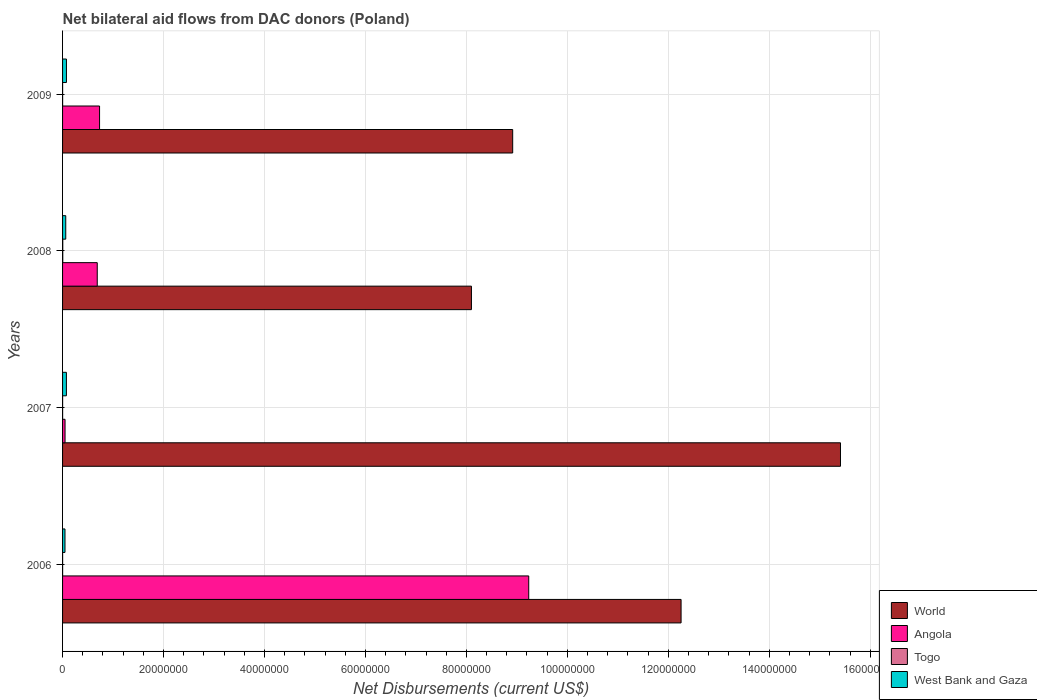Are the number of bars per tick equal to the number of legend labels?
Make the answer very short. Yes. Are the number of bars on each tick of the Y-axis equal?
Your response must be concise. Yes. What is the label of the 2nd group of bars from the top?
Provide a succinct answer. 2008. What is the net bilateral aid flows in West Bank and Gaza in 2009?
Provide a short and direct response. 7.70e+05. Across all years, what is the maximum net bilateral aid flows in World?
Keep it short and to the point. 1.54e+08. Across all years, what is the minimum net bilateral aid flows in West Bank and Gaza?
Your answer should be very brief. 4.80e+05. In which year was the net bilateral aid flows in Togo minimum?
Give a very brief answer. 2006. What is the total net bilateral aid flows in West Bank and Gaza in the graph?
Make the answer very short. 2.64e+06. What is the difference between the net bilateral aid flows in West Bank and Gaza in 2006 and that in 2009?
Provide a short and direct response. -2.90e+05. What is the difference between the net bilateral aid flows in World in 2008 and the net bilateral aid flows in Togo in 2007?
Offer a terse response. 8.10e+07. What is the average net bilateral aid flows in World per year?
Provide a succinct answer. 1.12e+08. In the year 2008, what is the difference between the net bilateral aid flows in Angola and net bilateral aid flows in West Bank and Gaza?
Offer a terse response. 6.24e+06. In how many years, is the net bilateral aid flows in Togo greater than 152000000 US$?
Give a very brief answer. 0. What is the ratio of the net bilateral aid flows in West Bank and Gaza in 2008 to that in 2009?
Ensure brevity in your answer.  0.82. Is the net bilateral aid flows in World in 2006 less than that in 2007?
Give a very brief answer. Yes. Is the difference between the net bilateral aid flows in Angola in 2008 and 2009 greater than the difference between the net bilateral aid flows in West Bank and Gaza in 2008 and 2009?
Offer a terse response. No. What is the difference between the highest and the lowest net bilateral aid flows in World?
Ensure brevity in your answer.  7.31e+07. In how many years, is the net bilateral aid flows in Togo greater than the average net bilateral aid flows in Togo taken over all years?
Your answer should be compact. 1. What does the 4th bar from the top in 2007 represents?
Offer a terse response. World. What does the 1st bar from the bottom in 2007 represents?
Your response must be concise. World. Are all the bars in the graph horizontal?
Provide a succinct answer. Yes. How many years are there in the graph?
Offer a very short reply. 4. Does the graph contain any zero values?
Provide a short and direct response. No. What is the title of the graph?
Your response must be concise. Net bilateral aid flows from DAC donors (Poland). What is the label or title of the X-axis?
Offer a terse response. Net Disbursements (current US$). What is the Net Disbursements (current US$) in World in 2006?
Give a very brief answer. 1.23e+08. What is the Net Disbursements (current US$) of Angola in 2006?
Make the answer very short. 9.24e+07. What is the Net Disbursements (current US$) of Togo in 2006?
Offer a terse response. 10000. What is the Net Disbursements (current US$) of World in 2007?
Your response must be concise. 1.54e+08. What is the Net Disbursements (current US$) in Angola in 2007?
Offer a very short reply. 4.90e+05. What is the Net Disbursements (current US$) in West Bank and Gaza in 2007?
Your response must be concise. 7.60e+05. What is the Net Disbursements (current US$) in World in 2008?
Offer a terse response. 8.10e+07. What is the Net Disbursements (current US$) in Angola in 2008?
Offer a terse response. 6.87e+06. What is the Net Disbursements (current US$) in Togo in 2008?
Provide a short and direct response. 4.00e+04. What is the Net Disbursements (current US$) of West Bank and Gaza in 2008?
Provide a succinct answer. 6.30e+05. What is the Net Disbursements (current US$) of World in 2009?
Offer a very short reply. 8.92e+07. What is the Net Disbursements (current US$) in Angola in 2009?
Make the answer very short. 7.33e+06. What is the Net Disbursements (current US$) in West Bank and Gaza in 2009?
Make the answer very short. 7.70e+05. Across all years, what is the maximum Net Disbursements (current US$) of World?
Ensure brevity in your answer.  1.54e+08. Across all years, what is the maximum Net Disbursements (current US$) of Angola?
Provide a short and direct response. 9.24e+07. Across all years, what is the maximum Net Disbursements (current US$) in West Bank and Gaza?
Your answer should be very brief. 7.70e+05. Across all years, what is the minimum Net Disbursements (current US$) in World?
Offer a terse response. 8.10e+07. Across all years, what is the minimum Net Disbursements (current US$) of Angola?
Your answer should be very brief. 4.90e+05. Across all years, what is the minimum Net Disbursements (current US$) in Togo?
Offer a very short reply. 10000. What is the total Net Disbursements (current US$) in World in the graph?
Your answer should be very brief. 4.47e+08. What is the total Net Disbursements (current US$) in Angola in the graph?
Ensure brevity in your answer.  1.07e+08. What is the total Net Disbursements (current US$) of West Bank and Gaza in the graph?
Offer a terse response. 2.64e+06. What is the difference between the Net Disbursements (current US$) of World in 2006 and that in 2007?
Make the answer very short. -3.16e+07. What is the difference between the Net Disbursements (current US$) in Angola in 2006 and that in 2007?
Provide a short and direct response. 9.19e+07. What is the difference between the Net Disbursements (current US$) of West Bank and Gaza in 2006 and that in 2007?
Offer a terse response. -2.80e+05. What is the difference between the Net Disbursements (current US$) of World in 2006 and that in 2008?
Your response must be concise. 4.15e+07. What is the difference between the Net Disbursements (current US$) of Angola in 2006 and that in 2008?
Offer a terse response. 8.55e+07. What is the difference between the Net Disbursements (current US$) in West Bank and Gaza in 2006 and that in 2008?
Provide a short and direct response. -1.50e+05. What is the difference between the Net Disbursements (current US$) of World in 2006 and that in 2009?
Keep it short and to the point. 3.34e+07. What is the difference between the Net Disbursements (current US$) in Angola in 2006 and that in 2009?
Your answer should be compact. 8.50e+07. What is the difference between the Net Disbursements (current US$) of Togo in 2006 and that in 2009?
Your response must be concise. 0. What is the difference between the Net Disbursements (current US$) in World in 2007 and that in 2008?
Keep it short and to the point. 7.31e+07. What is the difference between the Net Disbursements (current US$) in Angola in 2007 and that in 2008?
Provide a short and direct response. -6.38e+06. What is the difference between the Net Disbursements (current US$) of Togo in 2007 and that in 2008?
Your answer should be very brief. -3.00e+04. What is the difference between the Net Disbursements (current US$) of West Bank and Gaza in 2007 and that in 2008?
Offer a very short reply. 1.30e+05. What is the difference between the Net Disbursements (current US$) of World in 2007 and that in 2009?
Offer a terse response. 6.49e+07. What is the difference between the Net Disbursements (current US$) of Angola in 2007 and that in 2009?
Keep it short and to the point. -6.84e+06. What is the difference between the Net Disbursements (current US$) of Togo in 2007 and that in 2009?
Give a very brief answer. 0. What is the difference between the Net Disbursements (current US$) of World in 2008 and that in 2009?
Ensure brevity in your answer.  -8.17e+06. What is the difference between the Net Disbursements (current US$) in Angola in 2008 and that in 2009?
Make the answer very short. -4.60e+05. What is the difference between the Net Disbursements (current US$) of World in 2006 and the Net Disbursements (current US$) of Angola in 2007?
Keep it short and to the point. 1.22e+08. What is the difference between the Net Disbursements (current US$) of World in 2006 and the Net Disbursements (current US$) of Togo in 2007?
Provide a short and direct response. 1.23e+08. What is the difference between the Net Disbursements (current US$) of World in 2006 and the Net Disbursements (current US$) of West Bank and Gaza in 2007?
Offer a terse response. 1.22e+08. What is the difference between the Net Disbursements (current US$) of Angola in 2006 and the Net Disbursements (current US$) of Togo in 2007?
Keep it short and to the point. 9.23e+07. What is the difference between the Net Disbursements (current US$) of Angola in 2006 and the Net Disbursements (current US$) of West Bank and Gaza in 2007?
Your answer should be very brief. 9.16e+07. What is the difference between the Net Disbursements (current US$) in Togo in 2006 and the Net Disbursements (current US$) in West Bank and Gaza in 2007?
Offer a terse response. -7.50e+05. What is the difference between the Net Disbursements (current US$) in World in 2006 and the Net Disbursements (current US$) in Angola in 2008?
Give a very brief answer. 1.16e+08. What is the difference between the Net Disbursements (current US$) in World in 2006 and the Net Disbursements (current US$) in Togo in 2008?
Keep it short and to the point. 1.22e+08. What is the difference between the Net Disbursements (current US$) of World in 2006 and the Net Disbursements (current US$) of West Bank and Gaza in 2008?
Give a very brief answer. 1.22e+08. What is the difference between the Net Disbursements (current US$) in Angola in 2006 and the Net Disbursements (current US$) in Togo in 2008?
Give a very brief answer. 9.23e+07. What is the difference between the Net Disbursements (current US$) in Angola in 2006 and the Net Disbursements (current US$) in West Bank and Gaza in 2008?
Make the answer very short. 9.17e+07. What is the difference between the Net Disbursements (current US$) of Togo in 2006 and the Net Disbursements (current US$) of West Bank and Gaza in 2008?
Provide a succinct answer. -6.20e+05. What is the difference between the Net Disbursements (current US$) in World in 2006 and the Net Disbursements (current US$) in Angola in 2009?
Make the answer very short. 1.15e+08. What is the difference between the Net Disbursements (current US$) in World in 2006 and the Net Disbursements (current US$) in Togo in 2009?
Make the answer very short. 1.23e+08. What is the difference between the Net Disbursements (current US$) in World in 2006 and the Net Disbursements (current US$) in West Bank and Gaza in 2009?
Offer a very short reply. 1.22e+08. What is the difference between the Net Disbursements (current US$) in Angola in 2006 and the Net Disbursements (current US$) in Togo in 2009?
Your answer should be compact. 9.23e+07. What is the difference between the Net Disbursements (current US$) in Angola in 2006 and the Net Disbursements (current US$) in West Bank and Gaza in 2009?
Your response must be concise. 9.16e+07. What is the difference between the Net Disbursements (current US$) in Togo in 2006 and the Net Disbursements (current US$) in West Bank and Gaza in 2009?
Offer a terse response. -7.60e+05. What is the difference between the Net Disbursements (current US$) of World in 2007 and the Net Disbursements (current US$) of Angola in 2008?
Make the answer very short. 1.47e+08. What is the difference between the Net Disbursements (current US$) of World in 2007 and the Net Disbursements (current US$) of Togo in 2008?
Offer a terse response. 1.54e+08. What is the difference between the Net Disbursements (current US$) of World in 2007 and the Net Disbursements (current US$) of West Bank and Gaza in 2008?
Keep it short and to the point. 1.53e+08. What is the difference between the Net Disbursements (current US$) in Angola in 2007 and the Net Disbursements (current US$) in Togo in 2008?
Your answer should be compact. 4.50e+05. What is the difference between the Net Disbursements (current US$) of Togo in 2007 and the Net Disbursements (current US$) of West Bank and Gaza in 2008?
Your answer should be compact. -6.20e+05. What is the difference between the Net Disbursements (current US$) of World in 2007 and the Net Disbursements (current US$) of Angola in 2009?
Ensure brevity in your answer.  1.47e+08. What is the difference between the Net Disbursements (current US$) in World in 2007 and the Net Disbursements (current US$) in Togo in 2009?
Give a very brief answer. 1.54e+08. What is the difference between the Net Disbursements (current US$) in World in 2007 and the Net Disbursements (current US$) in West Bank and Gaza in 2009?
Make the answer very short. 1.53e+08. What is the difference between the Net Disbursements (current US$) in Angola in 2007 and the Net Disbursements (current US$) in West Bank and Gaza in 2009?
Offer a terse response. -2.80e+05. What is the difference between the Net Disbursements (current US$) in Togo in 2007 and the Net Disbursements (current US$) in West Bank and Gaza in 2009?
Provide a short and direct response. -7.60e+05. What is the difference between the Net Disbursements (current US$) in World in 2008 and the Net Disbursements (current US$) in Angola in 2009?
Give a very brief answer. 7.37e+07. What is the difference between the Net Disbursements (current US$) in World in 2008 and the Net Disbursements (current US$) in Togo in 2009?
Your answer should be very brief. 8.10e+07. What is the difference between the Net Disbursements (current US$) of World in 2008 and the Net Disbursements (current US$) of West Bank and Gaza in 2009?
Your response must be concise. 8.02e+07. What is the difference between the Net Disbursements (current US$) in Angola in 2008 and the Net Disbursements (current US$) in Togo in 2009?
Your answer should be compact. 6.86e+06. What is the difference between the Net Disbursements (current US$) of Angola in 2008 and the Net Disbursements (current US$) of West Bank and Gaza in 2009?
Keep it short and to the point. 6.10e+06. What is the difference between the Net Disbursements (current US$) of Togo in 2008 and the Net Disbursements (current US$) of West Bank and Gaza in 2009?
Give a very brief answer. -7.30e+05. What is the average Net Disbursements (current US$) of World per year?
Ensure brevity in your answer.  1.12e+08. What is the average Net Disbursements (current US$) of Angola per year?
Keep it short and to the point. 2.68e+07. What is the average Net Disbursements (current US$) in Togo per year?
Provide a succinct answer. 1.75e+04. What is the average Net Disbursements (current US$) of West Bank and Gaza per year?
Ensure brevity in your answer.  6.60e+05. In the year 2006, what is the difference between the Net Disbursements (current US$) in World and Net Disbursements (current US$) in Angola?
Offer a very short reply. 3.02e+07. In the year 2006, what is the difference between the Net Disbursements (current US$) of World and Net Disbursements (current US$) of Togo?
Offer a very short reply. 1.23e+08. In the year 2006, what is the difference between the Net Disbursements (current US$) in World and Net Disbursements (current US$) in West Bank and Gaza?
Offer a very short reply. 1.22e+08. In the year 2006, what is the difference between the Net Disbursements (current US$) in Angola and Net Disbursements (current US$) in Togo?
Ensure brevity in your answer.  9.23e+07. In the year 2006, what is the difference between the Net Disbursements (current US$) in Angola and Net Disbursements (current US$) in West Bank and Gaza?
Your response must be concise. 9.19e+07. In the year 2006, what is the difference between the Net Disbursements (current US$) in Togo and Net Disbursements (current US$) in West Bank and Gaza?
Offer a terse response. -4.70e+05. In the year 2007, what is the difference between the Net Disbursements (current US$) in World and Net Disbursements (current US$) in Angola?
Your answer should be very brief. 1.54e+08. In the year 2007, what is the difference between the Net Disbursements (current US$) in World and Net Disbursements (current US$) in Togo?
Give a very brief answer. 1.54e+08. In the year 2007, what is the difference between the Net Disbursements (current US$) in World and Net Disbursements (current US$) in West Bank and Gaza?
Provide a succinct answer. 1.53e+08. In the year 2007, what is the difference between the Net Disbursements (current US$) in Angola and Net Disbursements (current US$) in Togo?
Give a very brief answer. 4.80e+05. In the year 2007, what is the difference between the Net Disbursements (current US$) in Angola and Net Disbursements (current US$) in West Bank and Gaza?
Keep it short and to the point. -2.70e+05. In the year 2007, what is the difference between the Net Disbursements (current US$) in Togo and Net Disbursements (current US$) in West Bank and Gaza?
Your answer should be very brief. -7.50e+05. In the year 2008, what is the difference between the Net Disbursements (current US$) of World and Net Disbursements (current US$) of Angola?
Your response must be concise. 7.41e+07. In the year 2008, what is the difference between the Net Disbursements (current US$) in World and Net Disbursements (current US$) in Togo?
Provide a short and direct response. 8.10e+07. In the year 2008, what is the difference between the Net Disbursements (current US$) in World and Net Disbursements (current US$) in West Bank and Gaza?
Your answer should be very brief. 8.04e+07. In the year 2008, what is the difference between the Net Disbursements (current US$) in Angola and Net Disbursements (current US$) in Togo?
Ensure brevity in your answer.  6.83e+06. In the year 2008, what is the difference between the Net Disbursements (current US$) of Angola and Net Disbursements (current US$) of West Bank and Gaza?
Keep it short and to the point. 6.24e+06. In the year 2008, what is the difference between the Net Disbursements (current US$) in Togo and Net Disbursements (current US$) in West Bank and Gaza?
Give a very brief answer. -5.90e+05. In the year 2009, what is the difference between the Net Disbursements (current US$) of World and Net Disbursements (current US$) of Angola?
Offer a terse response. 8.18e+07. In the year 2009, what is the difference between the Net Disbursements (current US$) of World and Net Disbursements (current US$) of Togo?
Ensure brevity in your answer.  8.92e+07. In the year 2009, what is the difference between the Net Disbursements (current US$) of World and Net Disbursements (current US$) of West Bank and Gaza?
Make the answer very short. 8.84e+07. In the year 2009, what is the difference between the Net Disbursements (current US$) of Angola and Net Disbursements (current US$) of Togo?
Ensure brevity in your answer.  7.32e+06. In the year 2009, what is the difference between the Net Disbursements (current US$) of Angola and Net Disbursements (current US$) of West Bank and Gaza?
Your answer should be very brief. 6.56e+06. In the year 2009, what is the difference between the Net Disbursements (current US$) in Togo and Net Disbursements (current US$) in West Bank and Gaza?
Your answer should be very brief. -7.60e+05. What is the ratio of the Net Disbursements (current US$) of World in 2006 to that in 2007?
Provide a short and direct response. 0.8. What is the ratio of the Net Disbursements (current US$) of Angola in 2006 to that in 2007?
Give a very brief answer. 188.47. What is the ratio of the Net Disbursements (current US$) in Togo in 2006 to that in 2007?
Make the answer very short. 1. What is the ratio of the Net Disbursements (current US$) in West Bank and Gaza in 2006 to that in 2007?
Your answer should be compact. 0.63. What is the ratio of the Net Disbursements (current US$) in World in 2006 to that in 2008?
Provide a short and direct response. 1.51. What is the ratio of the Net Disbursements (current US$) of Angola in 2006 to that in 2008?
Your answer should be very brief. 13.44. What is the ratio of the Net Disbursements (current US$) of Togo in 2006 to that in 2008?
Your answer should be very brief. 0.25. What is the ratio of the Net Disbursements (current US$) of West Bank and Gaza in 2006 to that in 2008?
Your answer should be compact. 0.76. What is the ratio of the Net Disbursements (current US$) of World in 2006 to that in 2009?
Give a very brief answer. 1.37. What is the ratio of the Net Disbursements (current US$) of Angola in 2006 to that in 2009?
Offer a very short reply. 12.6. What is the ratio of the Net Disbursements (current US$) in Togo in 2006 to that in 2009?
Provide a short and direct response. 1. What is the ratio of the Net Disbursements (current US$) of West Bank and Gaza in 2006 to that in 2009?
Offer a very short reply. 0.62. What is the ratio of the Net Disbursements (current US$) of World in 2007 to that in 2008?
Your answer should be very brief. 1.9. What is the ratio of the Net Disbursements (current US$) in Angola in 2007 to that in 2008?
Ensure brevity in your answer.  0.07. What is the ratio of the Net Disbursements (current US$) of Togo in 2007 to that in 2008?
Ensure brevity in your answer.  0.25. What is the ratio of the Net Disbursements (current US$) of West Bank and Gaza in 2007 to that in 2008?
Ensure brevity in your answer.  1.21. What is the ratio of the Net Disbursements (current US$) in World in 2007 to that in 2009?
Give a very brief answer. 1.73. What is the ratio of the Net Disbursements (current US$) in Angola in 2007 to that in 2009?
Offer a very short reply. 0.07. What is the ratio of the Net Disbursements (current US$) in West Bank and Gaza in 2007 to that in 2009?
Make the answer very short. 0.99. What is the ratio of the Net Disbursements (current US$) of World in 2008 to that in 2009?
Your response must be concise. 0.91. What is the ratio of the Net Disbursements (current US$) of Angola in 2008 to that in 2009?
Your answer should be compact. 0.94. What is the ratio of the Net Disbursements (current US$) of Togo in 2008 to that in 2009?
Your answer should be compact. 4. What is the ratio of the Net Disbursements (current US$) of West Bank and Gaza in 2008 to that in 2009?
Provide a succinct answer. 0.82. What is the difference between the highest and the second highest Net Disbursements (current US$) of World?
Ensure brevity in your answer.  3.16e+07. What is the difference between the highest and the second highest Net Disbursements (current US$) of Angola?
Offer a very short reply. 8.50e+07. What is the difference between the highest and the lowest Net Disbursements (current US$) of World?
Your answer should be compact. 7.31e+07. What is the difference between the highest and the lowest Net Disbursements (current US$) of Angola?
Keep it short and to the point. 9.19e+07. What is the difference between the highest and the lowest Net Disbursements (current US$) in Togo?
Your answer should be compact. 3.00e+04. What is the difference between the highest and the lowest Net Disbursements (current US$) in West Bank and Gaza?
Offer a terse response. 2.90e+05. 